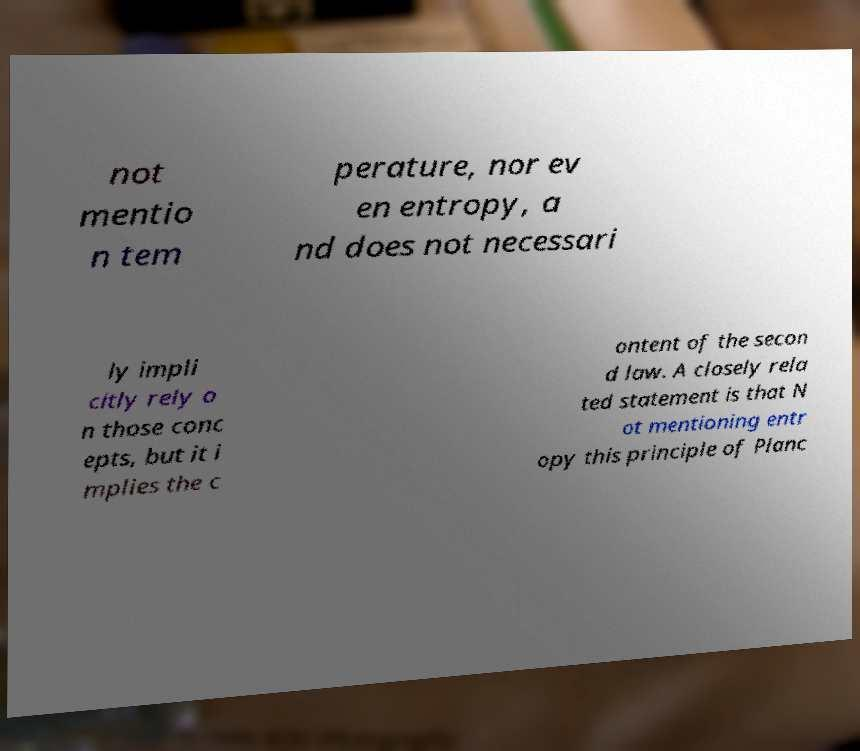Could you assist in decoding the text presented in this image and type it out clearly? not mentio n tem perature, nor ev en entropy, a nd does not necessari ly impli citly rely o n those conc epts, but it i mplies the c ontent of the secon d law. A closely rela ted statement is that N ot mentioning entr opy this principle of Planc 